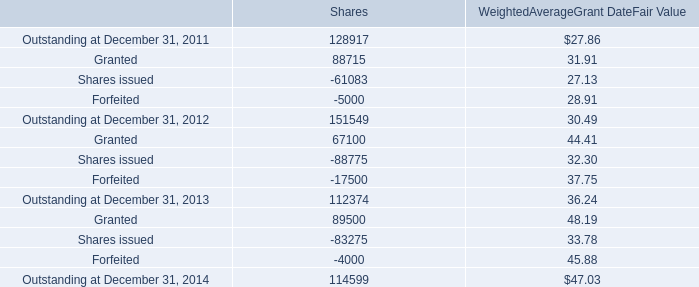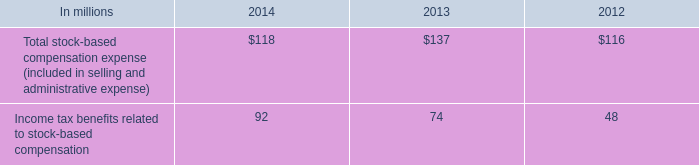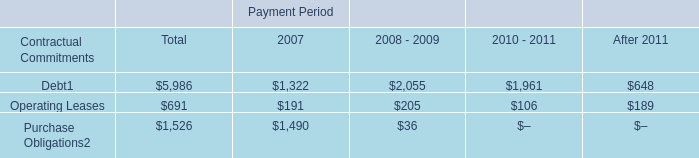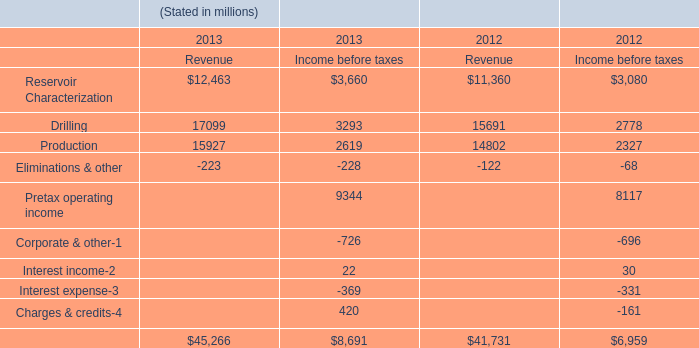what's the total amount of Purchase Obligations of Payment Period 2007, and Shares issued of Shares ? 
Computations: (1490.0 + 61083.0)
Answer: 62573.0. 